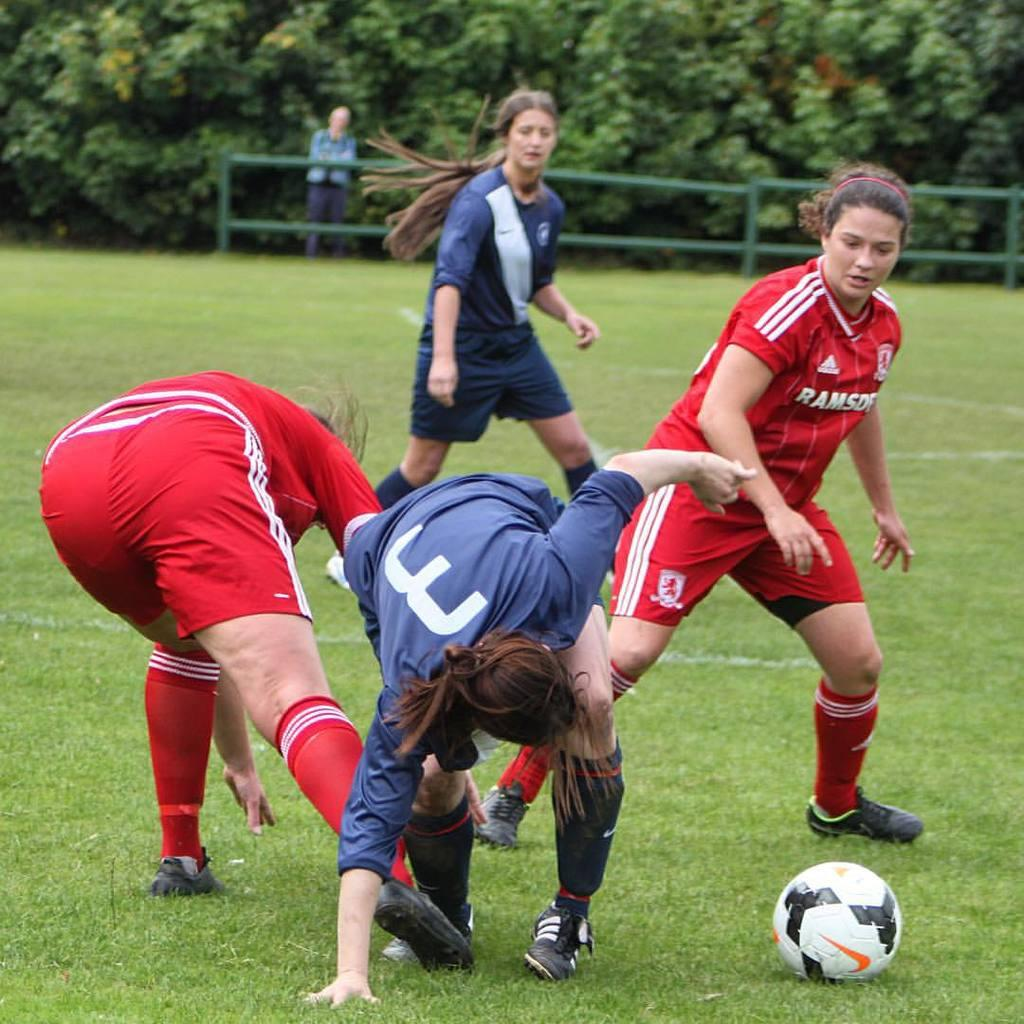<image>
Relay a brief, clear account of the picture shown. a group of soccer players with one that has the number 3 